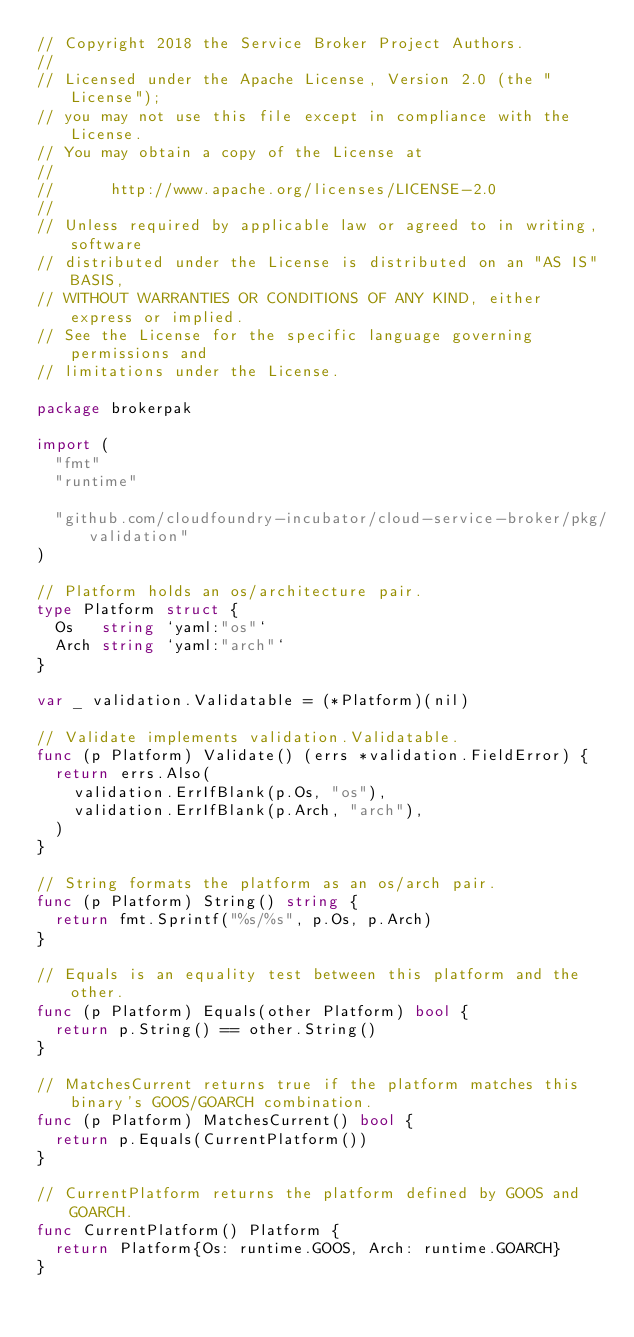<code> <loc_0><loc_0><loc_500><loc_500><_Go_>// Copyright 2018 the Service Broker Project Authors.
//
// Licensed under the Apache License, Version 2.0 (the "License");
// you may not use this file except in compliance with the License.
// You may obtain a copy of the License at
//
//      http://www.apache.org/licenses/LICENSE-2.0
//
// Unless required by applicable law or agreed to in writing, software
// distributed under the License is distributed on an "AS IS" BASIS,
// WITHOUT WARRANTIES OR CONDITIONS OF ANY KIND, either express or implied.
// See the License for the specific language governing permissions and
// limitations under the License.

package brokerpak

import (
	"fmt"
	"runtime"

	"github.com/cloudfoundry-incubator/cloud-service-broker/pkg/validation"
)

// Platform holds an os/architecture pair.
type Platform struct {
	Os   string `yaml:"os"`
	Arch string `yaml:"arch"`
}

var _ validation.Validatable = (*Platform)(nil)

// Validate implements validation.Validatable.
func (p Platform) Validate() (errs *validation.FieldError) {
	return errs.Also(
		validation.ErrIfBlank(p.Os, "os"),
		validation.ErrIfBlank(p.Arch, "arch"),
	)
}

// String formats the platform as an os/arch pair.
func (p Platform) String() string {
	return fmt.Sprintf("%s/%s", p.Os, p.Arch)
}

// Equals is an equality test between this platform and the other.
func (p Platform) Equals(other Platform) bool {
	return p.String() == other.String()
}

// MatchesCurrent returns true if the platform matches this binary's GOOS/GOARCH combination.
func (p Platform) MatchesCurrent() bool {
	return p.Equals(CurrentPlatform())
}

// CurrentPlatform returns the platform defined by GOOS and GOARCH.
func CurrentPlatform() Platform {
	return Platform{Os: runtime.GOOS, Arch: runtime.GOARCH}
}
</code> 